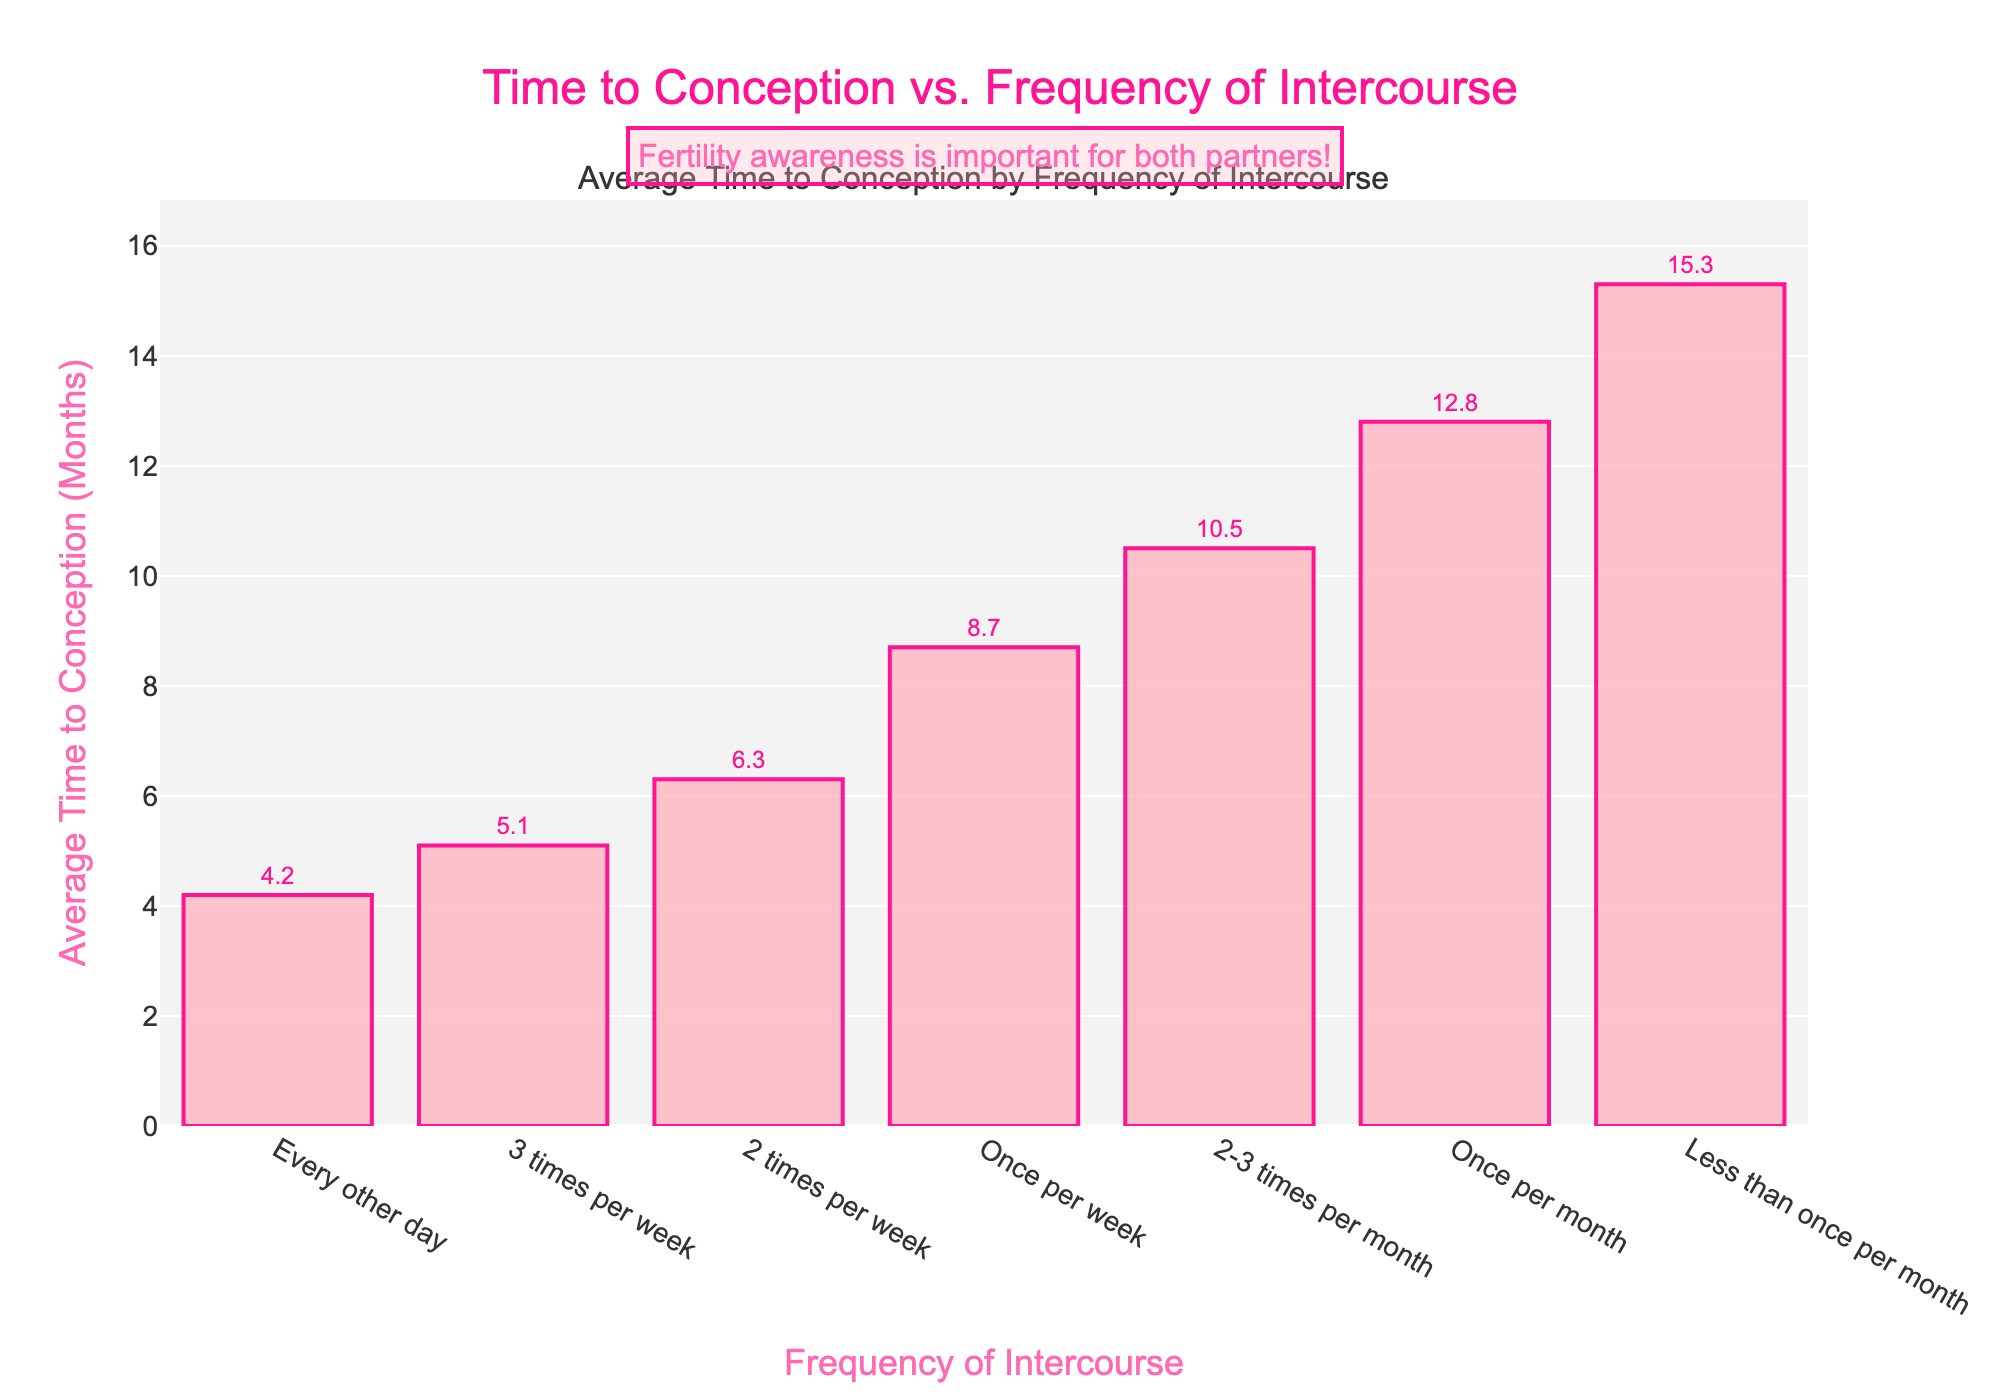What is the average time to conception for couples having intercourse every other day? Look at the bar labeled "Every other day" and refer to the value indicated on the bar. The average time to conception is 4.2 months.
Answer: 4.2 months Which frequency of intercourse has the longest average time to conception? Identify the bar with the highest value on the y-axis. The bar labeled "Less than once per month" has the highest value of 15.3 months.
Answer: Less than once per month How much longer does it take on average for couples having intercourse once per month to conceive compared to those doing it every other day? Subtract the value for "Every other day" from "Once per month". The calculation is 12.8 - 4.2 = 8.6 months.
Answer: 8.6 months What is the total average time to conception for all the frequencies combined? Add up all the values: 4.2 + 5.1 + 6.3 + 8.7 + 10.5 + 12.8 + 15.3 = 62.9 months.
Answer: 62.9 months If a couple increases their frequency from once per week to 3 times per week, how much time could they potentially save? Subtract the value for "3 times per week" from "Once per week". The calculation is 8.7 - 5.1 = 3.6 months.
Answer: 3.6 months Which two frequencies have the smallest difference in their average time to conception? Compare the differences between consecutive frequencies. The smallest difference is between "Every other day" (4.2) and "3 times per week" (5.1), which is 5.1 - 4.2 = 0.9 months.
Answer: Every other day and 3 times per week Describe the trend in the average time to conception as the frequency of intercourse decreases. As the frequency of intercourse decreases, the average time to conception increases, indicating an inverse relationship. The bars progressively get higher as the frequency lessens.
Answer: Increases What is the average time to conception for intercourse occurring less than 2-3 times per month? Consider the bars for "Once per month" and "Less than once per month" then average the values: (12.8 + 15.3) / 2 = 14.05 months.
Answer: 14.05 months Which frequency of intercourse has an average time to conception closest to 6 months? Look at the bar values and identify the one closest to 6 months. The "2 times per week" bar is 6.3 months, closest to 6.
Answer: 2 times per week 